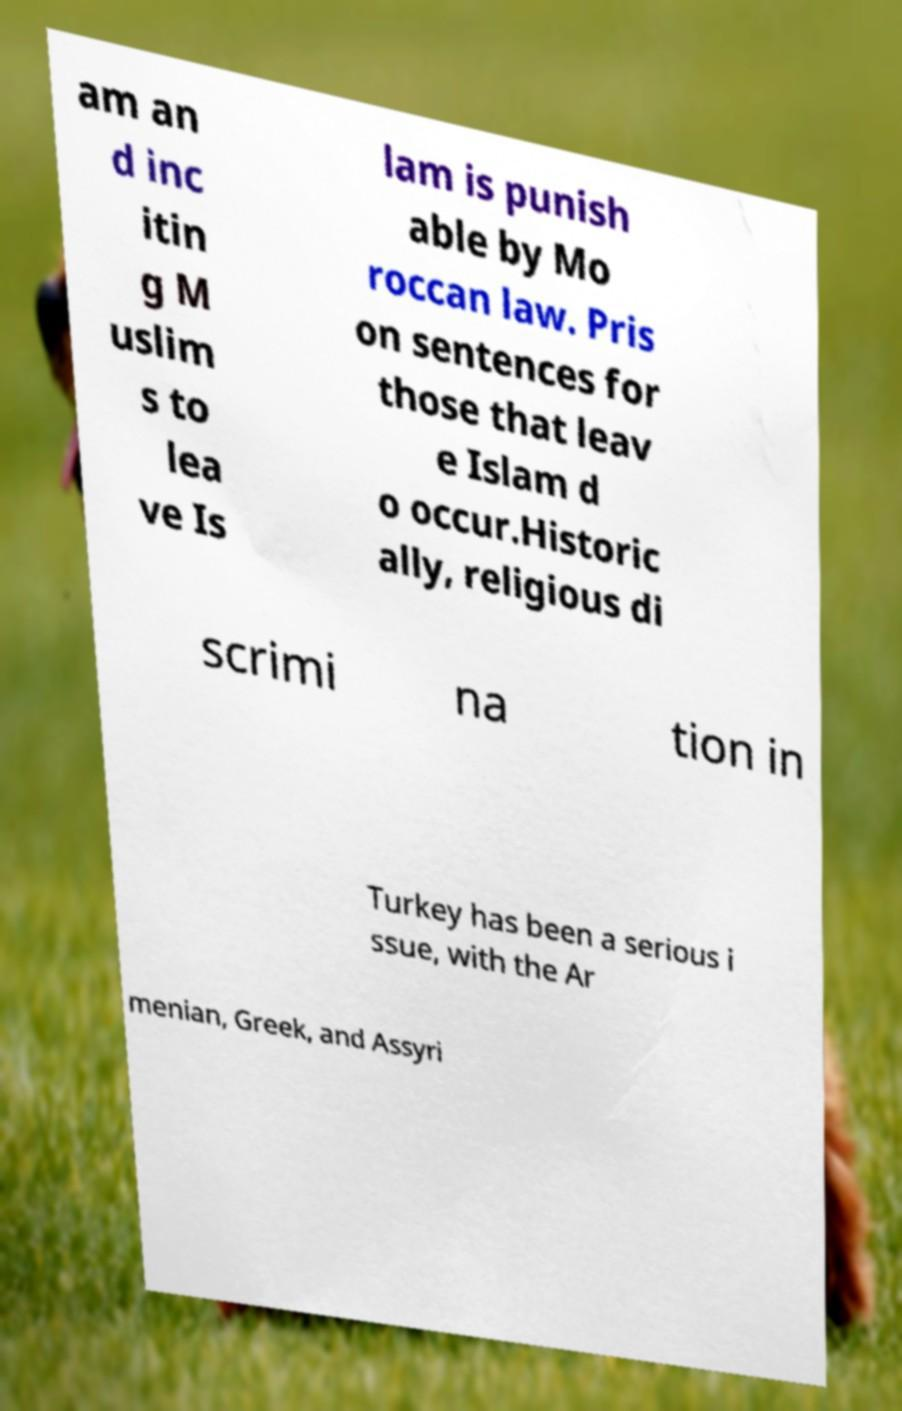Could you assist in decoding the text presented in this image and type it out clearly? am an d inc itin g M uslim s to lea ve Is lam is punish able by Mo roccan law. Pris on sentences for those that leav e Islam d o occur.Historic ally, religious di scrimi na tion in Turkey has been a serious i ssue, with the Ar menian, Greek, and Assyri 